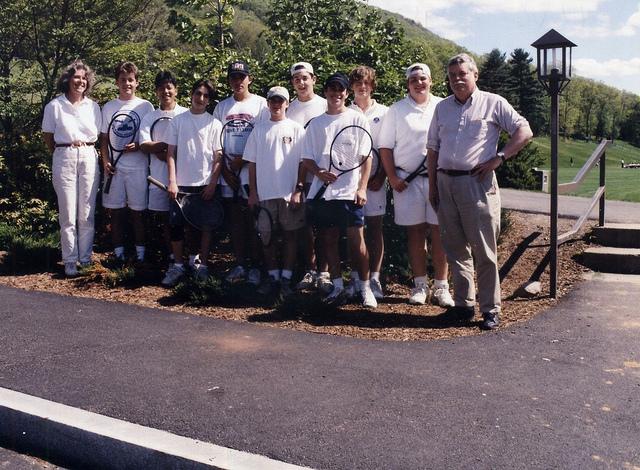Could this be a race track?
Short answer required. No. Are they all wearing white?
Be succinct. Yes. What type of team is this?
Quick response, please. Tennis. What sport do they play?
Short answer required. Tennis. 